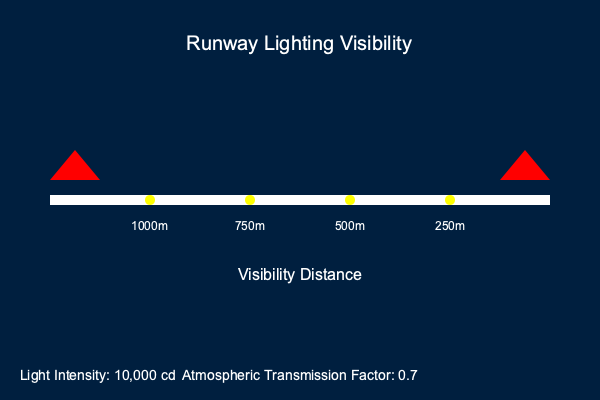Based on the runway lighting system depicted in the image, calculate the minimum visibility distance at which a pilot can safely identify the runway threshold lights. Assume the pilot's eye sensitivity threshold is $10^{-6}$ lux and use the inverse square law for light intensity. How does this compare to the standard Category I ILS approach minimum of 550 meters? To solve this problem, we'll use the inverse square law and the given information:

1. Light intensity at source (I): 10,000 cd
2. Atmospheric transmission factor (T): 0.7
3. Pilot's eye sensitivity threshold (E): $10^{-6}$ lux

Step 1: Use the inverse square law formula:
$E = \frac{I \cdot T}{d^2}$

Step 2: Rearrange the formula to solve for distance (d):
$d^2 = \frac{I \cdot T}{E}$
$d = \sqrt{\frac{I \cdot T}{E}}$

Step 3: Plug in the values:
$d = \sqrt{\frac{10,000 \cdot 0.7}{10^{-6}}}$

Step 4: Simplify and calculate:
$d = \sqrt{7 \cdot 10^9} \approx 83,666$ meters

Step 5: Convert to kilometers:
83,666 meters ≈ 83.7 km

Step 6: Compare to Category I ILS approach minimum:
The calculated visibility distance (83.7 km) is significantly greater than the Category I ILS approach minimum of 550 meters.

This result indicates that the runway lighting system is highly effective, allowing pilots to identify the threshold lights from a much greater distance than the minimum required for a Category I ILS approach.
Answer: 83.7 km; significantly exceeds Cat I ILS minimum 